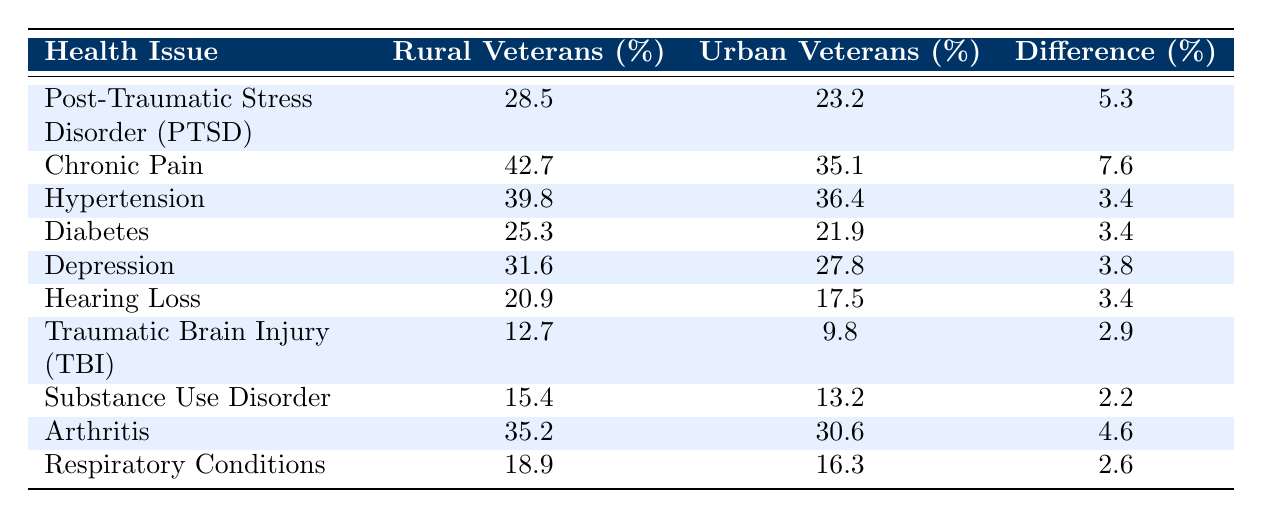What's the percentage of rural veterans reporting Chronic Pain? The table states that 42.7% of rural veterans report Chronic Pain.
Answer: 42.7% Which health issue has the highest percentage of rural veterans? Chronic Pain has the highest percentage at 42.7%.
Answer: Chronic Pain What is the difference in the percentage of veterans reporting PTSD between rural and urban areas? The table shows a difference of 5.3% (28.5% - 23.2%) for PTSD between rural and urban veterans.
Answer: 5.3% Is it true that more rural veterans report Depression than urban veterans? Yes, the table shows that 31.6% of rural veterans report Depression compared to 27.8% of urban veterans.
Answer: Yes What is the average percentage of reported Chronic Pain and Hypertension among rural veterans? The percentages for Chronic Pain (42.7%) and Hypertension (39.8%) sum to 82.5%. The average is 82.5% / 2 = 41.25%.
Answer: 41.25% How many health issues listed have a difference of 4% or more between rural and urban veterans? There are three health issues: Chronic Pain (7.6%), PTSD (5.3%), and Arthritis (4.6%), which all have differences of 4% or more.
Answer: 3 Compare the percentage of Hearing Loss between rural and urban veterans. Is it significant? Rural veterans report 20.9% for Hearing Loss, while urban veterans report 17.5%, resulting in a difference of 3.4%, which some may find significant.
Answer: Yes Which condition shows the least difference in percentage between rural and urban veterans? Traumatic Brain Injury (2.9%) shows the least difference compared to other health issues listed.
Answer: Traumatic Brain Injury What percentage of urban veterans report Diabetes? The table indicates that 21.9% of urban veterans report Diabetes.
Answer: 21.9% If you combine the percentages of veterans reporting Hearing Loss and Respiratory Conditions for rural veterans, what is the total? The total is 20.9% (Hearing Loss) + 18.9% (Respiratory Conditions) = 39.8%.
Answer: 39.8% 